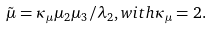Convert formula to latex. <formula><loc_0><loc_0><loc_500><loc_500>\tilde { \mu } = \kappa _ { \mu } \mu _ { 2 } \mu _ { 3 } / \lambda _ { 2 } , w i t h \kappa _ { \mu } = 2 .</formula> 